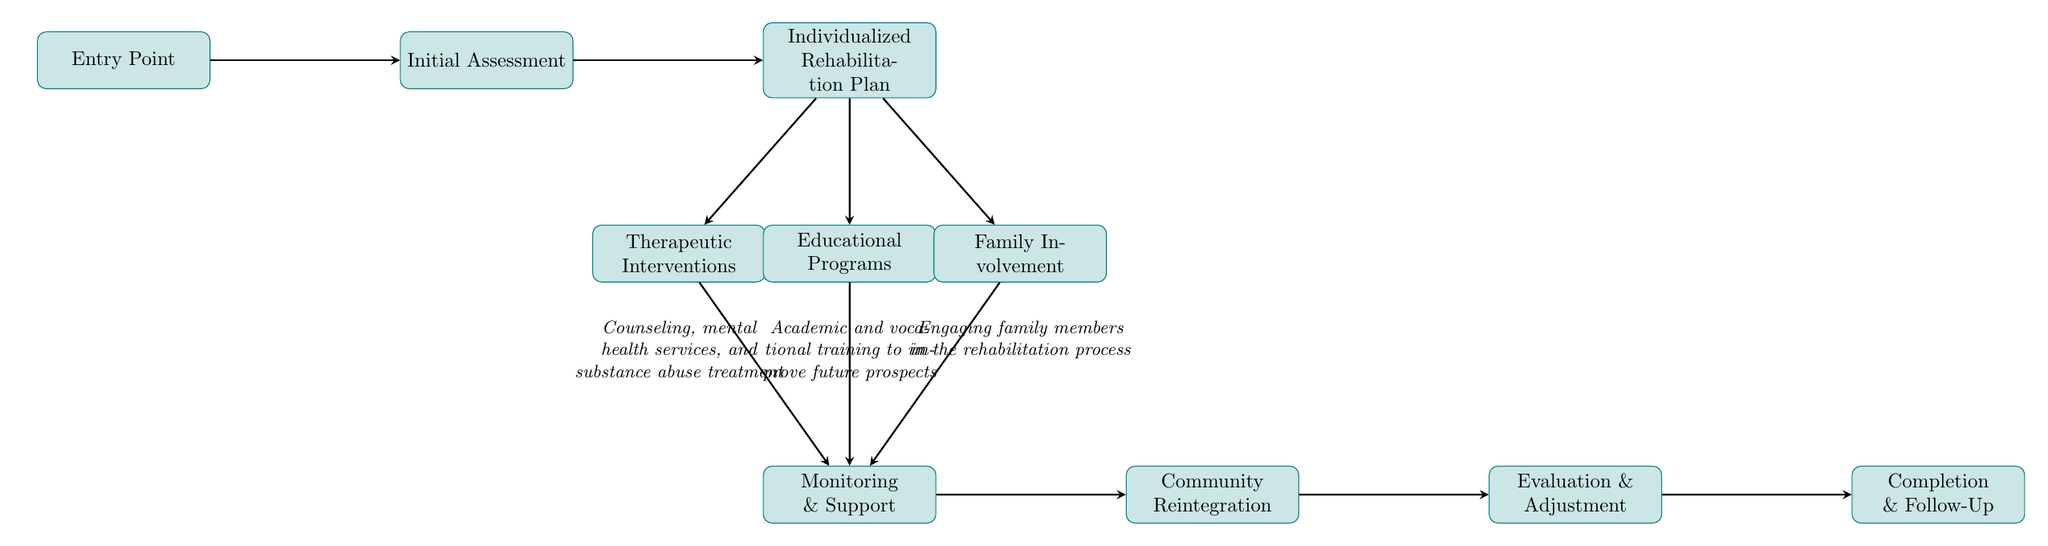What is the first step in the rehabilitation process? The diagram indicates that the first step is the "Entry Point," where the juvenile enters the justice system.
Answer: Entry Point How many main nodes are in the diagram? By counting the nodes in the diagram, we find there are a total of 10 main nodes that represent different stages of the rehabilitation process.
Answer: 10 What comes after the "Initial Assessment"? The diagram shows that after the "Initial Assessment," the next step is "Individualized Rehabilitation Plan."
Answer: Individualized Rehabilitation Plan What type of interventions are included under the "Therapeutic Interventions"? The description under the "Therapeutic Interventions" node mentions counseling, mental health services, and substance abuse treatment, which indicates the type of interventions provided.
Answer: Counseling, mental health services, and substance abuse treatment How is family involved in the rehabilitation process? The diagram includes a node labeled "Family Involvement," which indicates that family members are engaged in the rehabilitation process as part of the support system for juveniles.
Answer: Engaging family members in the rehabilitation process What happens after "Monitoring & Support"? According to the diagram, the next step after "Monitoring & Support" is "Community Reintegration," highlighting the progression towards re-entering society.
Answer: Community Reintegration What is evaluated during the "Evaluation & Adjustment" step? The node for "Evaluation & Adjustment" indicates that periodic reviews of the rehabilitation plan occur to make necessary adjustments based on progress, showing a focus on continuous improvement.
Answer: Periodic reviews of the rehabilitation plan Which node connects to both "Educational Programs" and "Family Involvement"? In the diagram, the "Individualized Rehabilitation Plan" node has direct connections to both "Educational Programs" and "Family Involvement," emphasizing their integral role in the overall rehabilitation strategy.
Answer: Individualized Rehabilitation Plan 